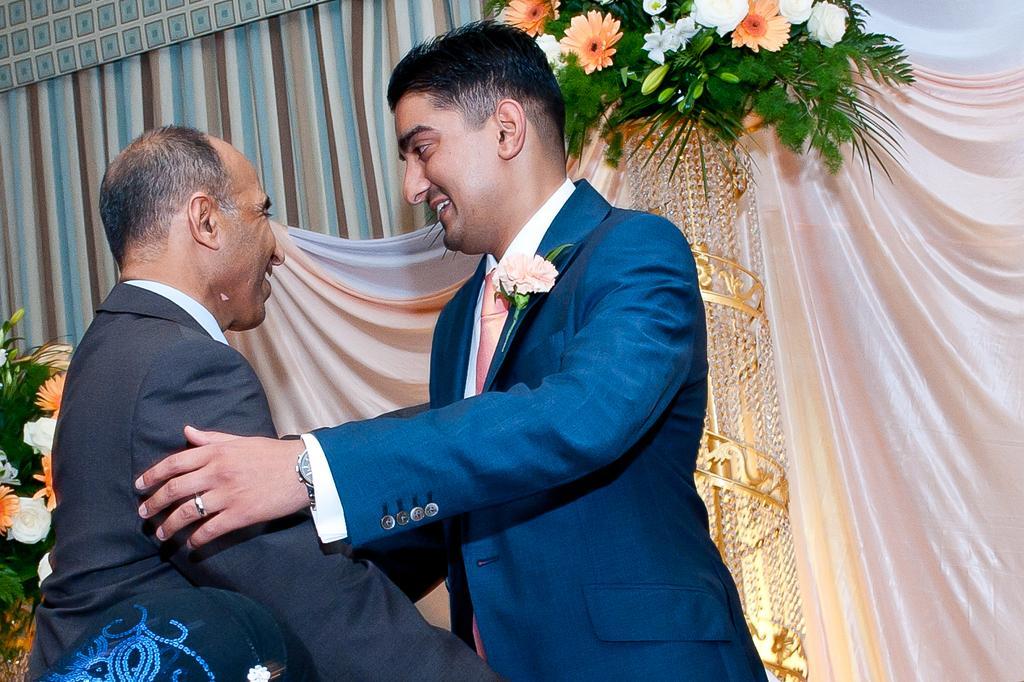In one or two sentences, can you explain what this image depicts? In the image we can see two men standing, wearing clothes and the right side man is wearing a wrist watch and finger ring. Here we can see a flower bouquet and curtains. 